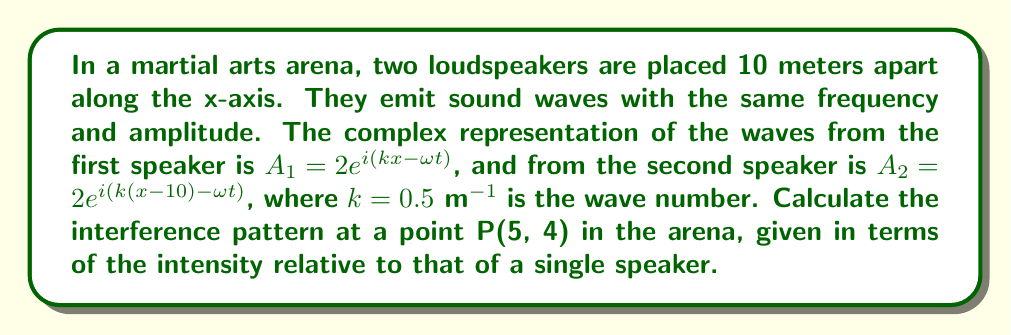Can you answer this question? To solve this problem, we'll follow these steps:

1) First, we need to calculate the distances $r_1$ and $r_2$ from each speaker to point P(5, 4).

   For speaker 1 at (0, 0): $r_1 = \sqrt{5^2 + 4^2} = \sqrt{41}$ m
   For speaker 2 at (10, 0): $r_2 = \sqrt{5^2 + 4^2} = \sqrt{41}$ m

2) Now, we can write the complex amplitudes at point P:

   $A_1 = 2e^{i(kr_1 - \omega t)} = 2e^{i(0.5\sqrt{41} - \omega t)}$
   $A_2 = 2e^{i(kr_2 - \omega t)} = 2e^{i(0.5\sqrt{41} - \omega t)}$

3) The total amplitude at P is the sum of these:

   $A_{total} = A_1 + A_2 = 2e^{i(0.5\sqrt{41} - \omega t)} + 2e^{i(0.5\sqrt{41} - \omega t)}$
               $= 4e^{i(0.5\sqrt{41} - \omega t)}$

4) The intensity is proportional to the square of the amplitude:

   $I \propto |A_{total}|^2 = |4e^{i(0.5\sqrt{41} - \omega t)}|^2 = 16$

5) To find the relative intensity, we compare this to the intensity of a single speaker:

   $I_{single} \propto |2e^{i(0.5\sqrt{41} - \omega t)}|^2 = 4$

6) The relative intensity is:

   $I_{relative} = \frac{I}{I_{single}} = \frac{16}{4} = 4$

Therefore, the intensity at point P is 4 times that of a single speaker.
Answer: 4 